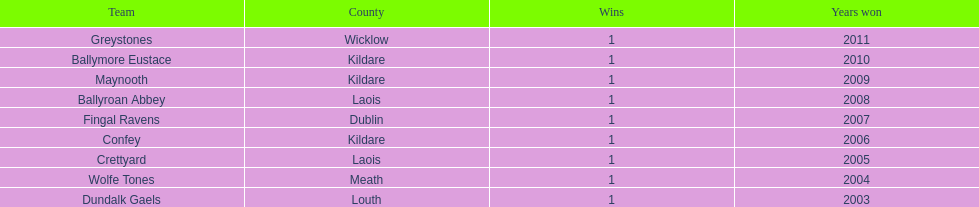After ballymore eustace, which team claimed victory? Greystones. 